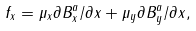Convert formula to latex. <formula><loc_0><loc_0><loc_500><loc_500>f _ { x } = \mu _ { x } \partial B _ { x } ^ { a } / \partial x + \mu _ { y } \partial B _ { y } ^ { a } / \partial x ,</formula> 